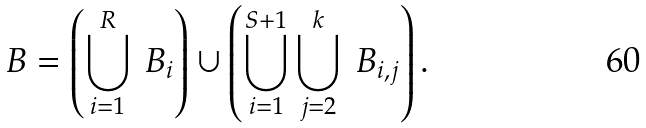Convert formula to latex. <formula><loc_0><loc_0><loc_500><loc_500>\ B = \left ( \bigcup _ { i = 1 } ^ { R } \ B _ { i } \right ) \cup \left ( \bigcup _ { i = 1 } ^ { S + 1 } \bigcup _ { j = 2 } ^ { k } \ B _ { i , j } \right ) .</formula> 